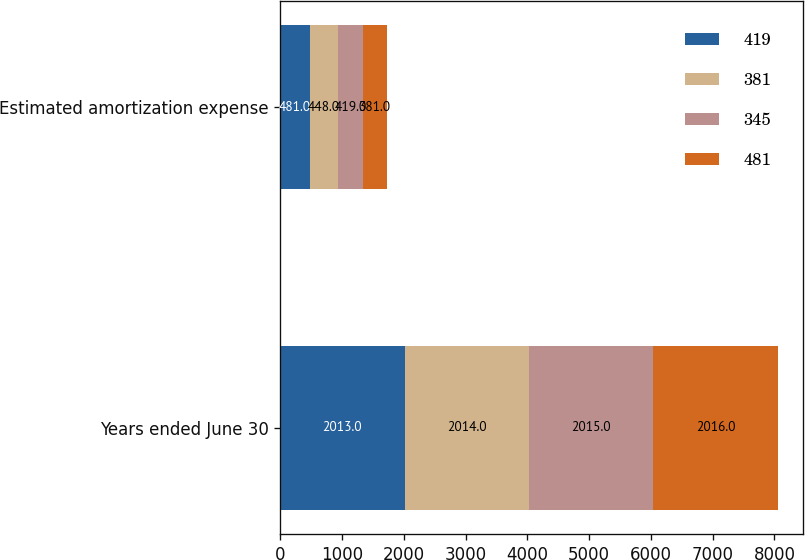Convert chart. <chart><loc_0><loc_0><loc_500><loc_500><stacked_bar_chart><ecel><fcel>Years ended June 30<fcel>Estimated amortization expense<nl><fcel>419<fcel>2013<fcel>481<nl><fcel>381<fcel>2014<fcel>448<nl><fcel>345<fcel>2015<fcel>419<nl><fcel>481<fcel>2016<fcel>381<nl></chart> 